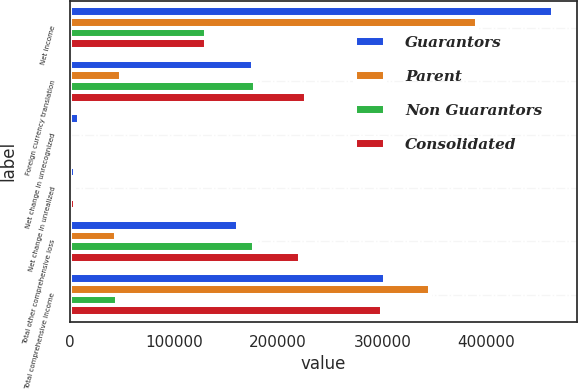Convert chart to OTSL. <chart><loc_0><loc_0><loc_500><loc_500><stacked_bar_chart><ecel><fcel>Net income<fcel>Foreign currency translation<fcel>Net change in unrecognized<fcel>Net change in unrealized<fcel>Total other comprehensive loss<fcel>Total comprehensive income<nl><fcel>Guarantors<fcel>463975<fcel>175639<fcel>9023<fcel>4911<fcel>161705<fcel>302270<nl><fcel>Parent<fcel>390486<fcel>48914<fcel>133<fcel>3962<fcel>44819<fcel>345667<nl><fcel>Non Guarantors<fcel>130647<fcel>177911<fcel>389<fcel>1061<fcel>176461<fcel>45814<nl><fcel>Consolidated<fcel>130647<fcel>226825<fcel>522<fcel>5023<fcel>221280<fcel>299853<nl></chart> 